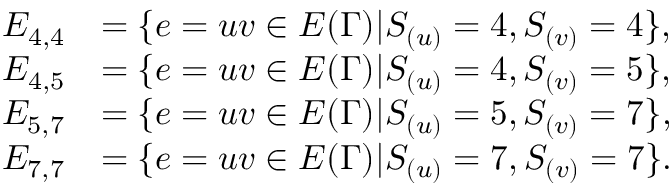<formula> <loc_0><loc_0><loc_500><loc_500>\begin{array} { r l } { E _ { 4 , 4 } } & { = \{ e = u v \in E ( \Gamma ) | S _ { ( u ) } = 4 , S _ { ( v ) } = 4 \} , } \\ { E _ { 4 , 5 } } & { = \{ e = u v \in E ( \Gamma ) | S _ { ( u ) } = 4 , S _ { ( v ) } = 5 \} , } \\ { E _ { 5 , 7 } } & { = \{ e = u v \in E ( \Gamma ) | S _ { ( u ) } = 5 , S _ { ( v ) } = 7 \} , } \\ { E _ { 7 , 7 } } & { = \{ e = u v \in E ( \Gamma ) | S _ { ( u ) } = 7 , S _ { ( v ) } = 7 \} . } \end{array}</formula> 